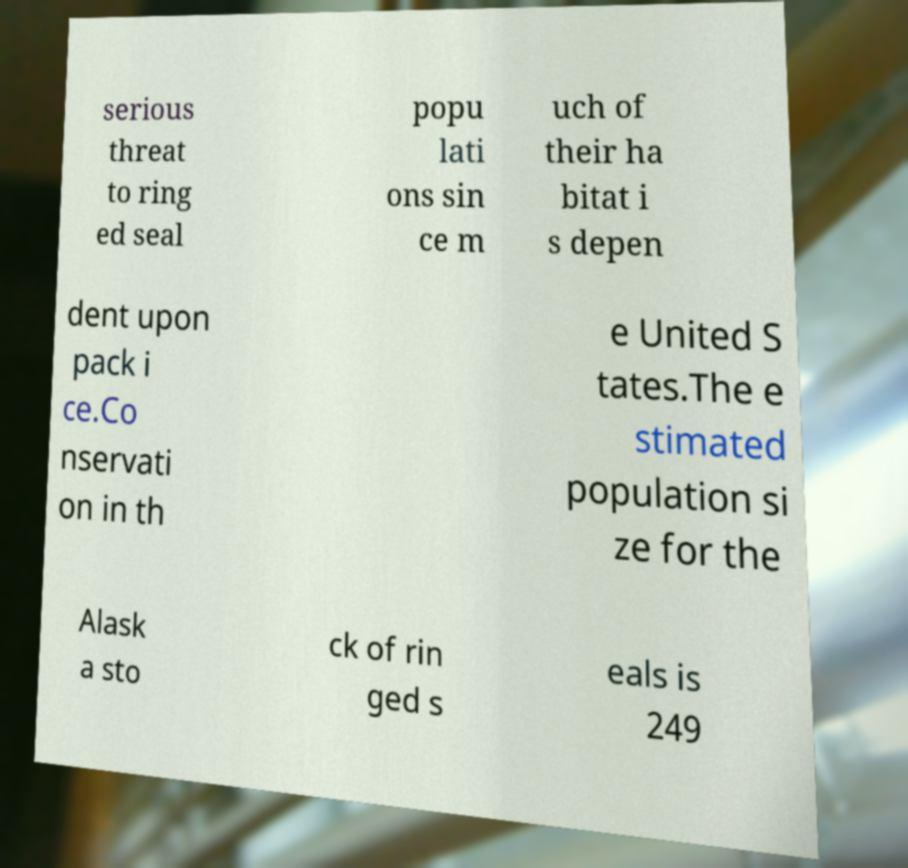Can you read and provide the text displayed in the image?This photo seems to have some interesting text. Can you extract and type it out for me? serious threat to ring ed seal popu lati ons sin ce m uch of their ha bitat i s depen dent upon pack i ce.Co nservati on in th e United S tates.The e stimated population si ze for the Alask a sto ck of rin ged s eals is 249 